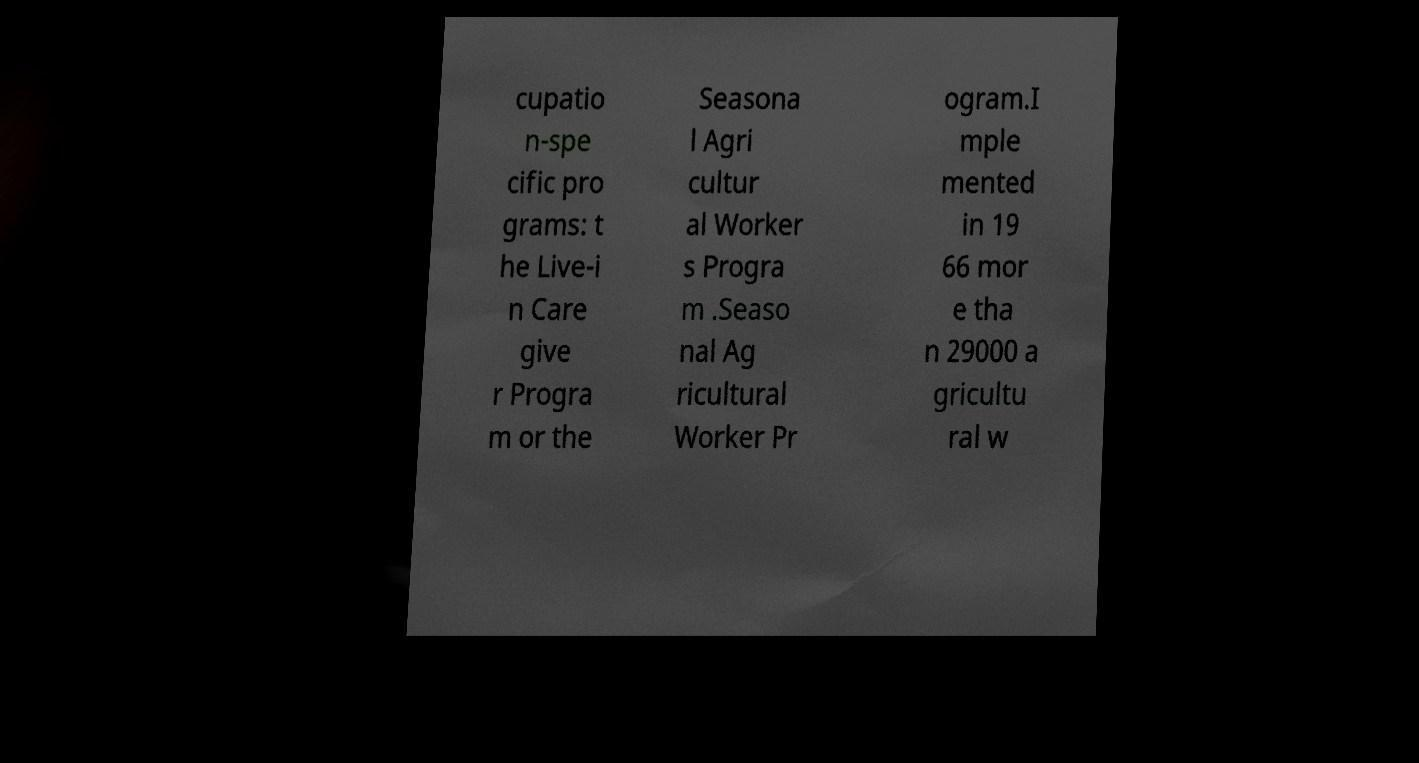Please identify and transcribe the text found in this image. cupatio n-spe cific pro grams: t he Live-i n Care give r Progra m or the Seasona l Agri cultur al Worker s Progra m .Seaso nal Ag ricultural Worker Pr ogram.I mple mented in 19 66 mor e tha n 29000 a gricultu ral w 